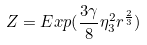<formula> <loc_0><loc_0><loc_500><loc_500>Z = E x p ( \frac { 3 \gamma } { 8 } \eta _ { 3 } ^ { 2 } r ^ { \frac { 2 } { 3 } } )</formula> 